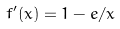<formula> <loc_0><loc_0><loc_500><loc_500>f ^ { \prime } ( x ) = 1 - e / x</formula> 